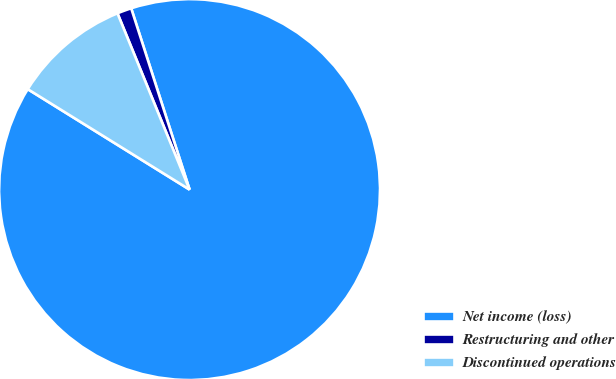Convert chart. <chart><loc_0><loc_0><loc_500><loc_500><pie_chart><fcel>Net income (loss)<fcel>Restructuring and other<fcel>Discontinued operations<nl><fcel>88.8%<fcel>1.22%<fcel>9.98%<nl></chart> 